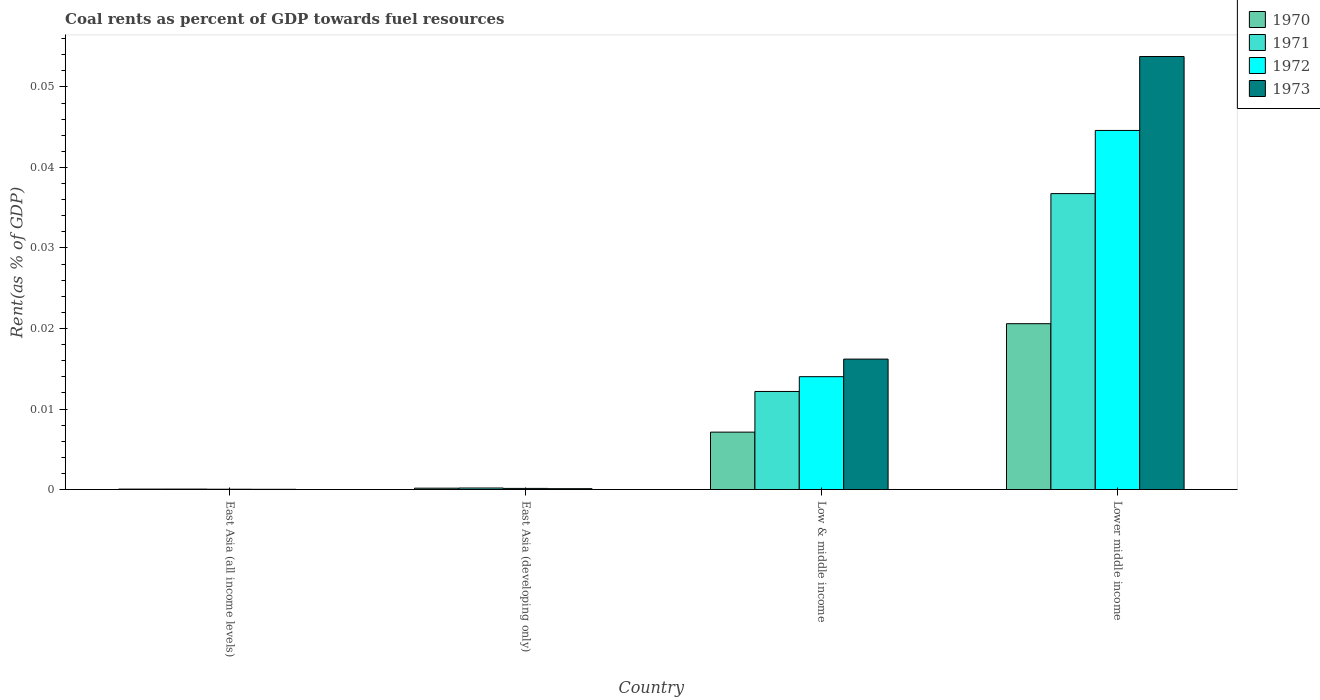How many groups of bars are there?
Ensure brevity in your answer.  4. Are the number of bars on each tick of the X-axis equal?
Keep it short and to the point. Yes. How many bars are there on the 2nd tick from the left?
Your response must be concise. 4. What is the label of the 2nd group of bars from the left?
Give a very brief answer. East Asia (developing only). In how many cases, is the number of bars for a given country not equal to the number of legend labels?
Ensure brevity in your answer.  0. What is the coal rent in 1973 in East Asia (all income levels)?
Offer a terse response. 2.64171247686014e-5. Across all countries, what is the maximum coal rent in 1973?
Your answer should be compact. 0.05. Across all countries, what is the minimum coal rent in 1972?
Your answer should be compact. 3.67730514806032e-5. In which country was the coal rent in 1971 maximum?
Give a very brief answer. Lower middle income. In which country was the coal rent in 1972 minimum?
Provide a succinct answer. East Asia (all income levels). What is the total coal rent in 1971 in the graph?
Offer a terse response. 0.05. What is the difference between the coal rent in 1973 in Low & middle income and that in Lower middle income?
Provide a succinct answer. -0.04. What is the difference between the coal rent in 1971 in Low & middle income and the coal rent in 1973 in East Asia (developing only)?
Offer a very short reply. 0.01. What is the average coal rent in 1973 per country?
Your answer should be compact. 0.02. What is the difference between the coal rent of/in 1970 and coal rent of/in 1971 in East Asia (developing only)?
Provide a short and direct response. -2.0133864270160002e-5. What is the ratio of the coal rent in 1973 in East Asia (all income levels) to that in East Asia (developing only)?
Keep it short and to the point. 0.26. Is the difference between the coal rent in 1970 in East Asia (all income levels) and Low & middle income greater than the difference between the coal rent in 1971 in East Asia (all income levels) and Low & middle income?
Offer a terse response. Yes. What is the difference between the highest and the second highest coal rent in 1973?
Provide a succinct answer. 0.04. What is the difference between the highest and the lowest coal rent in 1971?
Keep it short and to the point. 0.04. Is the sum of the coal rent in 1972 in East Asia (all income levels) and Low & middle income greater than the maximum coal rent in 1970 across all countries?
Provide a short and direct response. No. Is it the case that in every country, the sum of the coal rent in 1972 and coal rent in 1971 is greater than the coal rent in 1970?
Make the answer very short. Yes. Are all the bars in the graph horizontal?
Give a very brief answer. No. What is the difference between two consecutive major ticks on the Y-axis?
Your answer should be compact. 0.01. Does the graph contain grids?
Keep it short and to the point. No. Where does the legend appear in the graph?
Ensure brevity in your answer.  Top right. How are the legend labels stacked?
Make the answer very short. Vertical. What is the title of the graph?
Give a very brief answer. Coal rents as percent of GDP towards fuel resources. What is the label or title of the X-axis?
Offer a terse response. Country. What is the label or title of the Y-axis?
Your answer should be compact. Rent(as % of GDP). What is the Rent(as % of GDP) of 1970 in East Asia (all income levels)?
Your response must be concise. 5.1314079013758e-5. What is the Rent(as % of GDP) of 1971 in East Asia (all income levels)?
Offer a very short reply. 5.470114168356261e-5. What is the Rent(as % of GDP) in 1972 in East Asia (all income levels)?
Keep it short and to the point. 3.67730514806032e-5. What is the Rent(as % of GDP) of 1973 in East Asia (all income levels)?
Ensure brevity in your answer.  2.64171247686014e-5. What is the Rent(as % of GDP) in 1970 in East Asia (developing only)?
Provide a short and direct response. 0. What is the Rent(as % of GDP) of 1971 in East Asia (developing only)?
Make the answer very short. 0. What is the Rent(as % of GDP) of 1972 in East Asia (developing only)?
Offer a terse response. 0. What is the Rent(as % of GDP) of 1973 in East Asia (developing only)?
Make the answer very short. 0. What is the Rent(as % of GDP) of 1970 in Low & middle income?
Ensure brevity in your answer.  0.01. What is the Rent(as % of GDP) of 1971 in Low & middle income?
Provide a succinct answer. 0.01. What is the Rent(as % of GDP) in 1972 in Low & middle income?
Provide a succinct answer. 0.01. What is the Rent(as % of GDP) in 1973 in Low & middle income?
Your answer should be very brief. 0.02. What is the Rent(as % of GDP) of 1970 in Lower middle income?
Offer a terse response. 0.02. What is the Rent(as % of GDP) in 1971 in Lower middle income?
Your answer should be very brief. 0.04. What is the Rent(as % of GDP) in 1972 in Lower middle income?
Provide a succinct answer. 0.04. What is the Rent(as % of GDP) of 1973 in Lower middle income?
Ensure brevity in your answer.  0.05. Across all countries, what is the maximum Rent(as % of GDP) of 1970?
Offer a very short reply. 0.02. Across all countries, what is the maximum Rent(as % of GDP) of 1971?
Offer a very short reply. 0.04. Across all countries, what is the maximum Rent(as % of GDP) in 1972?
Offer a terse response. 0.04. Across all countries, what is the maximum Rent(as % of GDP) in 1973?
Ensure brevity in your answer.  0.05. Across all countries, what is the minimum Rent(as % of GDP) in 1970?
Ensure brevity in your answer.  5.1314079013758e-5. Across all countries, what is the minimum Rent(as % of GDP) of 1971?
Keep it short and to the point. 5.470114168356261e-5. Across all countries, what is the minimum Rent(as % of GDP) of 1972?
Offer a very short reply. 3.67730514806032e-5. Across all countries, what is the minimum Rent(as % of GDP) of 1973?
Offer a terse response. 2.64171247686014e-5. What is the total Rent(as % of GDP) of 1970 in the graph?
Give a very brief answer. 0.03. What is the total Rent(as % of GDP) of 1971 in the graph?
Ensure brevity in your answer.  0.05. What is the total Rent(as % of GDP) of 1972 in the graph?
Keep it short and to the point. 0.06. What is the total Rent(as % of GDP) in 1973 in the graph?
Your response must be concise. 0.07. What is the difference between the Rent(as % of GDP) of 1970 in East Asia (all income levels) and that in East Asia (developing only)?
Your response must be concise. -0. What is the difference between the Rent(as % of GDP) of 1971 in East Asia (all income levels) and that in East Asia (developing only)?
Your answer should be compact. -0. What is the difference between the Rent(as % of GDP) in 1972 in East Asia (all income levels) and that in East Asia (developing only)?
Your answer should be compact. -0. What is the difference between the Rent(as % of GDP) of 1973 in East Asia (all income levels) and that in East Asia (developing only)?
Provide a short and direct response. -0. What is the difference between the Rent(as % of GDP) in 1970 in East Asia (all income levels) and that in Low & middle income?
Offer a very short reply. -0.01. What is the difference between the Rent(as % of GDP) of 1971 in East Asia (all income levels) and that in Low & middle income?
Keep it short and to the point. -0.01. What is the difference between the Rent(as % of GDP) of 1972 in East Asia (all income levels) and that in Low & middle income?
Provide a short and direct response. -0.01. What is the difference between the Rent(as % of GDP) in 1973 in East Asia (all income levels) and that in Low & middle income?
Give a very brief answer. -0.02. What is the difference between the Rent(as % of GDP) in 1970 in East Asia (all income levels) and that in Lower middle income?
Ensure brevity in your answer.  -0.02. What is the difference between the Rent(as % of GDP) in 1971 in East Asia (all income levels) and that in Lower middle income?
Keep it short and to the point. -0.04. What is the difference between the Rent(as % of GDP) of 1972 in East Asia (all income levels) and that in Lower middle income?
Provide a short and direct response. -0.04. What is the difference between the Rent(as % of GDP) in 1973 in East Asia (all income levels) and that in Lower middle income?
Provide a short and direct response. -0.05. What is the difference between the Rent(as % of GDP) of 1970 in East Asia (developing only) and that in Low & middle income?
Keep it short and to the point. -0.01. What is the difference between the Rent(as % of GDP) of 1971 in East Asia (developing only) and that in Low & middle income?
Make the answer very short. -0.01. What is the difference between the Rent(as % of GDP) of 1972 in East Asia (developing only) and that in Low & middle income?
Your answer should be compact. -0.01. What is the difference between the Rent(as % of GDP) in 1973 in East Asia (developing only) and that in Low & middle income?
Offer a terse response. -0.02. What is the difference between the Rent(as % of GDP) of 1970 in East Asia (developing only) and that in Lower middle income?
Your answer should be compact. -0.02. What is the difference between the Rent(as % of GDP) in 1971 in East Asia (developing only) and that in Lower middle income?
Your response must be concise. -0.04. What is the difference between the Rent(as % of GDP) of 1972 in East Asia (developing only) and that in Lower middle income?
Keep it short and to the point. -0.04. What is the difference between the Rent(as % of GDP) of 1973 in East Asia (developing only) and that in Lower middle income?
Provide a succinct answer. -0.05. What is the difference between the Rent(as % of GDP) in 1970 in Low & middle income and that in Lower middle income?
Offer a very short reply. -0.01. What is the difference between the Rent(as % of GDP) of 1971 in Low & middle income and that in Lower middle income?
Your response must be concise. -0.02. What is the difference between the Rent(as % of GDP) of 1972 in Low & middle income and that in Lower middle income?
Offer a very short reply. -0.03. What is the difference between the Rent(as % of GDP) of 1973 in Low & middle income and that in Lower middle income?
Offer a terse response. -0.04. What is the difference between the Rent(as % of GDP) in 1970 in East Asia (all income levels) and the Rent(as % of GDP) in 1971 in East Asia (developing only)?
Provide a succinct answer. -0. What is the difference between the Rent(as % of GDP) of 1970 in East Asia (all income levels) and the Rent(as % of GDP) of 1972 in East Asia (developing only)?
Give a very brief answer. -0. What is the difference between the Rent(as % of GDP) of 1970 in East Asia (all income levels) and the Rent(as % of GDP) of 1973 in East Asia (developing only)?
Make the answer very short. -0. What is the difference between the Rent(as % of GDP) of 1971 in East Asia (all income levels) and the Rent(as % of GDP) of 1972 in East Asia (developing only)?
Ensure brevity in your answer.  -0. What is the difference between the Rent(as % of GDP) of 1971 in East Asia (all income levels) and the Rent(as % of GDP) of 1973 in East Asia (developing only)?
Give a very brief answer. -0. What is the difference between the Rent(as % of GDP) of 1972 in East Asia (all income levels) and the Rent(as % of GDP) of 1973 in East Asia (developing only)?
Your answer should be compact. -0. What is the difference between the Rent(as % of GDP) in 1970 in East Asia (all income levels) and the Rent(as % of GDP) in 1971 in Low & middle income?
Provide a short and direct response. -0.01. What is the difference between the Rent(as % of GDP) in 1970 in East Asia (all income levels) and the Rent(as % of GDP) in 1972 in Low & middle income?
Your answer should be compact. -0.01. What is the difference between the Rent(as % of GDP) of 1970 in East Asia (all income levels) and the Rent(as % of GDP) of 1973 in Low & middle income?
Offer a terse response. -0.02. What is the difference between the Rent(as % of GDP) in 1971 in East Asia (all income levels) and the Rent(as % of GDP) in 1972 in Low & middle income?
Offer a very short reply. -0.01. What is the difference between the Rent(as % of GDP) of 1971 in East Asia (all income levels) and the Rent(as % of GDP) of 1973 in Low & middle income?
Your response must be concise. -0.02. What is the difference between the Rent(as % of GDP) of 1972 in East Asia (all income levels) and the Rent(as % of GDP) of 1973 in Low & middle income?
Provide a short and direct response. -0.02. What is the difference between the Rent(as % of GDP) in 1970 in East Asia (all income levels) and the Rent(as % of GDP) in 1971 in Lower middle income?
Keep it short and to the point. -0.04. What is the difference between the Rent(as % of GDP) in 1970 in East Asia (all income levels) and the Rent(as % of GDP) in 1972 in Lower middle income?
Provide a short and direct response. -0.04. What is the difference between the Rent(as % of GDP) of 1970 in East Asia (all income levels) and the Rent(as % of GDP) of 1973 in Lower middle income?
Your answer should be very brief. -0.05. What is the difference between the Rent(as % of GDP) of 1971 in East Asia (all income levels) and the Rent(as % of GDP) of 1972 in Lower middle income?
Offer a terse response. -0.04. What is the difference between the Rent(as % of GDP) of 1971 in East Asia (all income levels) and the Rent(as % of GDP) of 1973 in Lower middle income?
Keep it short and to the point. -0.05. What is the difference between the Rent(as % of GDP) of 1972 in East Asia (all income levels) and the Rent(as % of GDP) of 1973 in Lower middle income?
Provide a short and direct response. -0.05. What is the difference between the Rent(as % of GDP) in 1970 in East Asia (developing only) and the Rent(as % of GDP) in 1971 in Low & middle income?
Offer a very short reply. -0.01. What is the difference between the Rent(as % of GDP) of 1970 in East Asia (developing only) and the Rent(as % of GDP) of 1972 in Low & middle income?
Provide a short and direct response. -0.01. What is the difference between the Rent(as % of GDP) in 1970 in East Asia (developing only) and the Rent(as % of GDP) in 1973 in Low & middle income?
Make the answer very short. -0.02. What is the difference between the Rent(as % of GDP) in 1971 in East Asia (developing only) and the Rent(as % of GDP) in 1972 in Low & middle income?
Provide a short and direct response. -0.01. What is the difference between the Rent(as % of GDP) of 1971 in East Asia (developing only) and the Rent(as % of GDP) of 1973 in Low & middle income?
Your response must be concise. -0.02. What is the difference between the Rent(as % of GDP) in 1972 in East Asia (developing only) and the Rent(as % of GDP) in 1973 in Low & middle income?
Your answer should be compact. -0.02. What is the difference between the Rent(as % of GDP) in 1970 in East Asia (developing only) and the Rent(as % of GDP) in 1971 in Lower middle income?
Offer a very short reply. -0.04. What is the difference between the Rent(as % of GDP) of 1970 in East Asia (developing only) and the Rent(as % of GDP) of 1972 in Lower middle income?
Provide a short and direct response. -0.04. What is the difference between the Rent(as % of GDP) of 1970 in East Asia (developing only) and the Rent(as % of GDP) of 1973 in Lower middle income?
Ensure brevity in your answer.  -0.05. What is the difference between the Rent(as % of GDP) in 1971 in East Asia (developing only) and the Rent(as % of GDP) in 1972 in Lower middle income?
Offer a terse response. -0.04. What is the difference between the Rent(as % of GDP) of 1971 in East Asia (developing only) and the Rent(as % of GDP) of 1973 in Lower middle income?
Your answer should be very brief. -0.05. What is the difference between the Rent(as % of GDP) of 1972 in East Asia (developing only) and the Rent(as % of GDP) of 1973 in Lower middle income?
Give a very brief answer. -0.05. What is the difference between the Rent(as % of GDP) in 1970 in Low & middle income and the Rent(as % of GDP) in 1971 in Lower middle income?
Ensure brevity in your answer.  -0.03. What is the difference between the Rent(as % of GDP) of 1970 in Low & middle income and the Rent(as % of GDP) of 1972 in Lower middle income?
Your response must be concise. -0.04. What is the difference between the Rent(as % of GDP) of 1970 in Low & middle income and the Rent(as % of GDP) of 1973 in Lower middle income?
Offer a terse response. -0.05. What is the difference between the Rent(as % of GDP) of 1971 in Low & middle income and the Rent(as % of GDP) of 1972 in Lower middle income?
Provide a succinct answer. -0.03. What is the difference between the Rent(as % of GDP) in 1971 in Low & middle income and the Rent(as % of GDP) in 1973 in Lower middle income?
Your response must be concise. -0.04. What is the difference between the Rent(as % of GDP) in 1972 in Low & middle income and the Rent(as % of GDP) in 1973 in Lower middle income?
Provide a succinct answer. -0.04. What is the average Rent(as % of GDP) in 1970 per country?
Keep it short and to the point. 0.01. What is the average Rent(as % of GDP) in 1971 per country?
Keep it short and to the point. 0.01. What is the average Rent(as % of GDP) in 1972 per country?
Give a very brief answer. 0.01. What is the average Rent(as % of GDP) of 1973 per country?
Offer a very short reply. 0.02. What is the difference between the Rent(as % of GDP) in 1970 and Rent(as % of GDP) in 1971 in East Asia (all income levels)?
Keep it short and to the point. -0. What is the difference between the Rent(as % of GDP) of 1970 and Rent(as % of GDP) of 1972 in East Asia (all income levels)?
Offer a terse response. 0. What is the difference between the Rent(as % of GDP) of 1970 and Rent(as % of GDP) of 1973 in East Asia (all income levels)?
Your answer should be compact. 0. What is the difference between the Rent(as % of GDP) of 1971 and Rent(as % of GDP) of 1973 in East Asia (all income levels)?
Make the answer very short. 0. What is the difference between the Rent(as % of GDP) of 1970 and Rent(as % of GDP) of 1972 in East Asia (developing only)?
Your answer should be very brief. 0. What is the difference between the Rent(as % of GDP) of 1971 and Rent(as % of GDP) of 1972 in East Asia (developing only)?
Your response must be concise. 0. What is the difference between the Rent(as % of GDP) of 1972 and Rent(as % of GDP) of 1973 in East Asia (developing only)?
Offer a terse response. 0. What is the difference between the Rent(as % of GDP) in 1970 and Rent(as % of GDP) in 1971 in Low & middle income?
Make the answer very short. -0.01. What is the difference between the Rent(as % of GDP) of 1970 and Rent(as % of GDP) of 1972 in Low & middle income?
Your answer should be compact. -0.01. What is the difference between the Rent(as % of GDP) in 1970 and Rent(as % of GDP) in 1973 in Low & middle income?
Provide a succinct answer. -0.01. What is the difference between the Rent(as % of GDP) in 1971 and Rent(as % of GDP) in 1972 in Low & middle income?
Make the answer very short. -0. What is the difference between the Rent(as % of GDP) of 1971 and Rent(as % of GDP) of 1973 in Low & middle income?
Give a very brief answer. -0. What is the difference between the Rent(as % of GDP) of 1972 and Rent(as % of GDP) of 1973 in Low & middle income?
Provide a short and direct response. -0. What is the difference between the Rent(as % of GDP) in 1970 and Rent(as % of GDP) in 1971 in Lower middle income?
Provide a succinct answer. -0.02. What is the difference between the Rent(as % of GDP) of 1970 and Rent(as % of GDP) of 1972 in Lower middle income?
Your response must be concise. -0.02. What is the difference between the Rent(as % of GDP) in 1970 and Rent(as % of GDP) in 1973 in Lower middle income?
Provide a succinct answer. -0.03. What is the difference between the Rent(as % of GDP) in 1971 and Rent(as % of GDP) in 1972 in Lower middle income?
Your response must be concise. -0.01. What is the difference between the Rent(as % of GDP) of 1971 and Rent(as % of GDP) of 1973 in Lower middle income?
Provide a succinct answer. -0.02. What is the difference between the Rent(as % of GDP) in 1972 and Rent(as % of GDP) in 1973 in Lower middle income?
Provide a succinct answer. -0.01. What is the ratio of the Rent(as % of GDP) of 1970 in East Asia (all income levels) to that in East Asia (developing only)?
Your response must be concise. 0.31. What is the ratio of the Rent(as % of GDP) in 1971 in East Asia (all income levels) to that in East Asia (developing only)?
Provide a short and direct response. 0.29. What is the ratio of the Rent(as % of GDP) of 1972 in East Asia (all income levels) to that in East Asia (developing only)?
Provide a succinct answer. 0.27. What is the ratio of the Rent(as % of GDP) of 1973 in East Asia (all income levels) to that in East Asia (developing only)?
Ensure brevity in your answer.  0.26. What is the ratio of the Rent(as % of GDP) of 1970 in East Asia (all income levels) to that in Low & middle income?
Make the answer very short. 0.01. What is the ratio of the Rent(as % of GDP) of 1971 in East Asia (all income levels) to that in Low & middle income?
Provide a short and direct response. 0. What is the ratio of the Rent(as % of GDP) in 1972 in East Asia (all income levels) to that in Low & middle income?
Keep it short and to the point. 0. What is the ratio of the Rent(as % of GDP) of 1973 in East Asia (all income levels) to that in Low & middle income?
Your response must be concise. 0. What is the ratio of the Rent(as % of GDP) in 1970 in East Asia (all income levels) to that in Lower middle income?
Offer a terse response. 0. What is the ratio of the Rent(as % of GDP) in 1971 in East Asia (all income levels) to that in Lower middle income?
Your response must be concise. 0. What is the ratio of the Rent(as % of GDP) of 1972 in East Asia (all income levels) to that in Lower middle income?
Make the answer very short. 0. What is the ratio of the Rent(as % of GDP) of 1973 in East Asia (all income levels) to that in Lower middle income?
Provide a short and direct response. 0. What is the ratio of the Rent(as % of GDP) of 1970 in East Asia (developing only) to that in Low & middle income?
Keep it short and to the point. 0.02. What is the ratio of the Rent(as % of GDP) in 1971 in East Asia (developing only) to that in Low & middle income?
Provide a short and direct response. 0.02. What is the ratio of the Rent(as % of GDP) in 1972 in East Asia (developing only) to that in Low & middle income?
Your answer should be compact. 0.01. What is the ratio of the Rent(as % of GDP) of 1973 in East Asia (developing only) to that in Low & middle income?
Keep it short and to the point. 0.01. What is the ratio of the Rent(as % of GDP) of 1970 in East Asia (developing only) to that in Lower middle income?
Provide a succinct answer. 0.01. What is the ratio of the Rent(as % of GDP) of 1971 in East Asia (developing only) to that in Lower middle income?
Offer a very short reply. 0.01. What is the ratio of the Rent(as % of GDP) of 1972 in East Asia (developing only) to that in Lower middle income?
Make the answer very short. 0. What is the ratio of the Rent(as % of GDP) of 1973 in East Asia (developing only) to that in Lower middle income?
Offer a terse response. 0. What is the ratio of the Rent(as % of GDP) in 1970 in Low & middle income to that in Lower middle income?
Make the answer very short. 0.35. What is the ratio of the Rent(as % of GDP) in 1971 in Low & middle income to that in Lower middle income?
Ensure brevity in your answer.  0.33. What is the ratio of the Rent(as % of GDP) of 1972 in Low & middle income to that in Lower middle income?
Your answer should be compact. 0.31. What is the ratio of the Rent(as % of GDP) of 1973 in Low & middle income to that in Lower middle income?
Provide a short and direct response. 0.3. What is the difference between the highest and the second highest Rent(as % of GDP) in 1970?
Your answer should be compact. 0.01. What is the difference between the highest and the second highest Rent(as % of GDP) of 1971?
Offer a very short reply. 0.02. What is the difference between the highest and the second highest Rent(as % of GDP) in 1972?
Offer a terse response. 0.03. What is the difference between the highest and the second highest Rent(as % of GDP) of 1973?
Your answer should be very brief. 0.04. What is the difference between the highest and the lowest Rent(as % of GDP) of 1970?
Provide a succinct answer. 0.02. What is the difference between the highest and the lowest Rent(as % of GDP) in 1971?
Ensure brevity in your answer.  0.04. What is the difference between the highest and the lowest Rent(as % of GDP) of 1972?
Provide a short and direct response. 0.04. What is the difference between the highest and the lowest Rent(as % of GDP) of 1973?
Your answer should be compact. 0.05. 